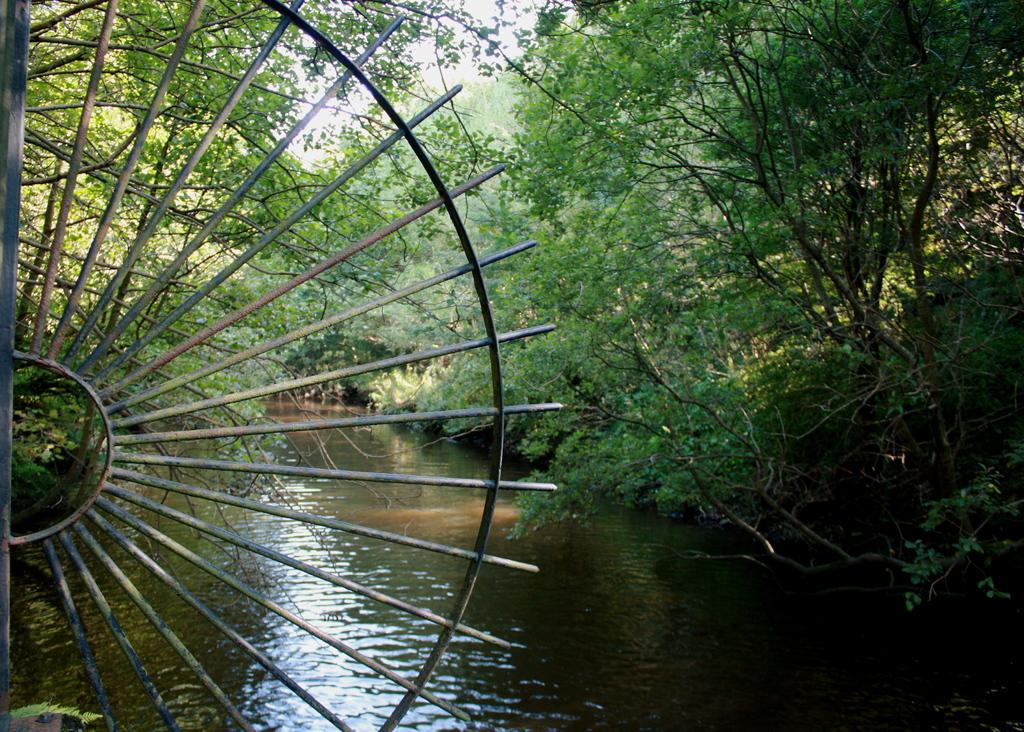What type of vegetation can be seen in the image? There are trees and plants in the image. What natural element is visible in the image? There is water visible in the image. What type of structure can be seen in the image? There is an iron grill in the image. What type of pest can be seen crawling on the trees in the image? There is no pest visible on the trees in the image. What type of machine is operating in the background of the image? There is no machine present in the image. 